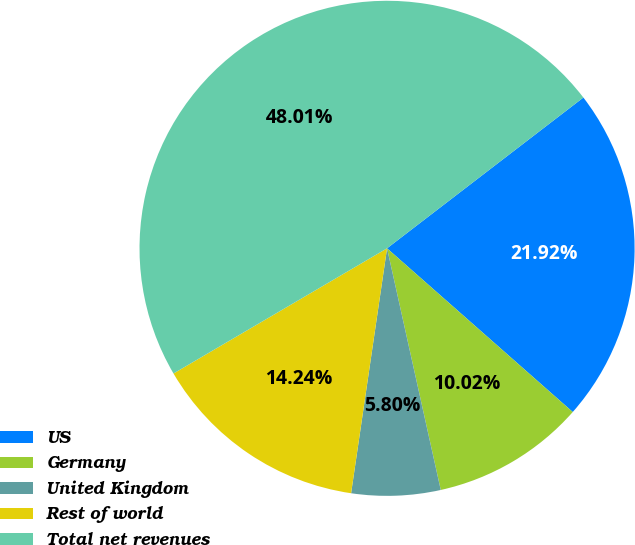Convert chart. <chart><loc_0><loc_0><loc_500><loc_500><pie_chart><fcel>US<fcel>Germany<fcel>United Kingdom<fcel>Rest of world<fcel>Total net revenues<nl><fcel>21.92%<fcel>10.02%<fcel>5.8%<fcel>14.24%<fcel>48.01%<nl></chart> 